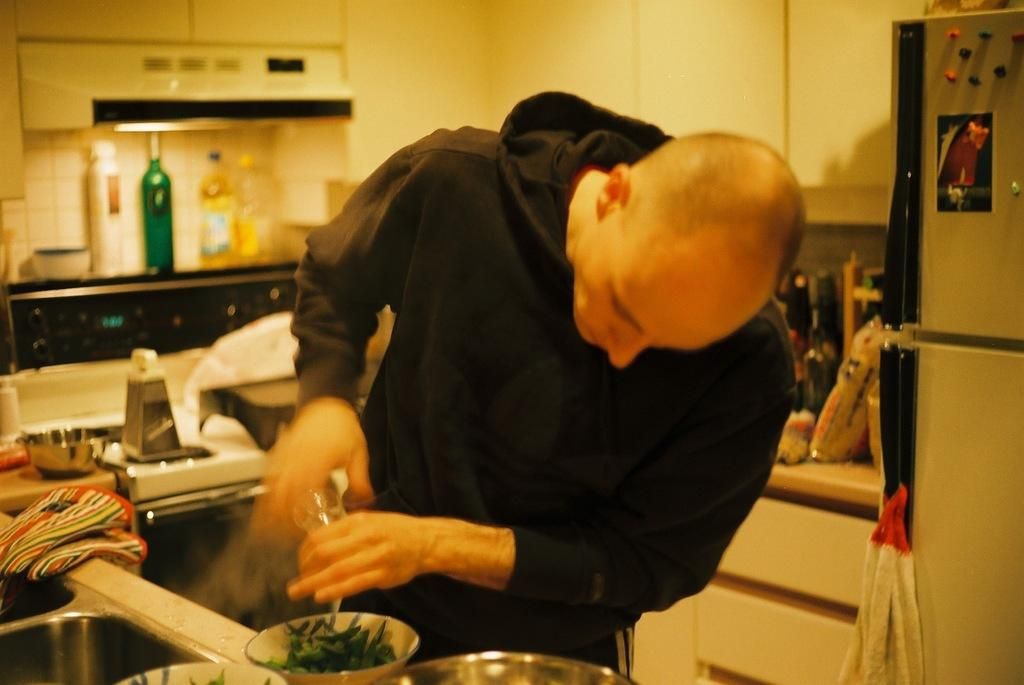What is the person in the image holding? There is a person holding an object in the image. What can be found inside the bowl in the image? There is a bowl with a food item in the image. What type of surface can be seen in the image? There are objects on a countertop in the image. What type of appliance is present in the image? There is a fridge in the image. What type of storage is present in the image? There are cupboards in the image. What type of containers can be seen in the image? There are bottles in the image. Where is the drain located in the image? There is no drain present in the image. What type of bulb is used to illuminate the box in the image? There is no bulb or box present in the image. 